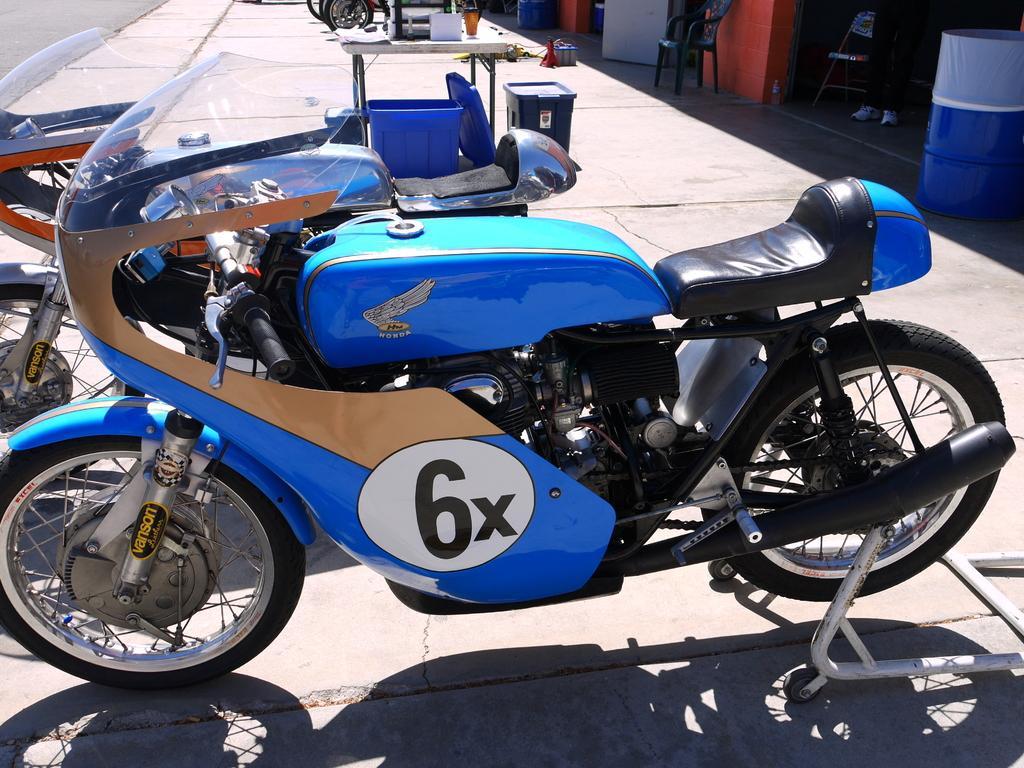Please provide a concise description of this image. In this image in the front there are bikes. In the center there is a table and there are bins. On the right side there is an empty chair, there is a drum and there are colour full walls, there is a person and in the background there are tyres and there are objects. 